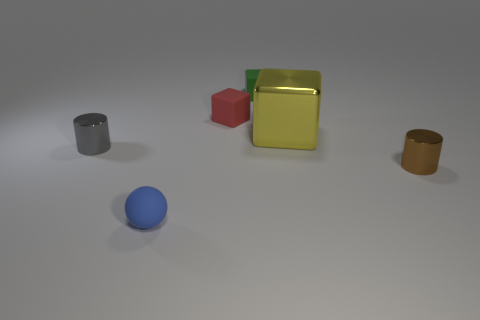What is the shape of the big yellow object?
Offer a terse response. Cube. Are there more rubber objects behind the tiny gray object than small cyan matte objects?
Offer a very short reply. Yes. Do the tiny red object and the yellow object behind the small blue sphere have the same shape?
Provide a succinct answer. Yes. Are there any large red matte cylinders?
Your answer should be compact. No. How many large objects are balls or rubber cubes?
Provide a succinct answer. 0. Is the number of metallic things that are to the left of the blue rubber sphere greater than the number of tiny metallic objects behind the tiny green block?
Provide a succinct answer. Yes. Do the small red cube and the cylinder right of the yellow metallic cube have the same material?
Provide a succinct answer. No. The big object is what color?
Your response must be concise. Yellow. There is a small shiny thing on the left side of the red cube; what shape is it?
Give a very brief answer. Cylinder. How many purple things are either tiny cylinders or tiny objects?
Offer a terse response. 0. 